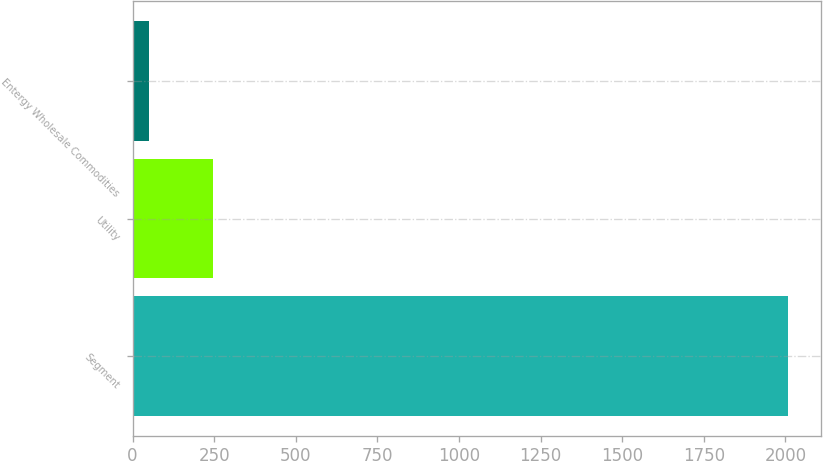Convert chart. <chart><loc_0><loc_0><loc_500><loc_500><bar_chart><fcel>Segment<fcel>Utility<fcel>Entergy Wholesale Commodities<nl><fcel>2009<fcel>246.8<fcel>51<nl></chart> 